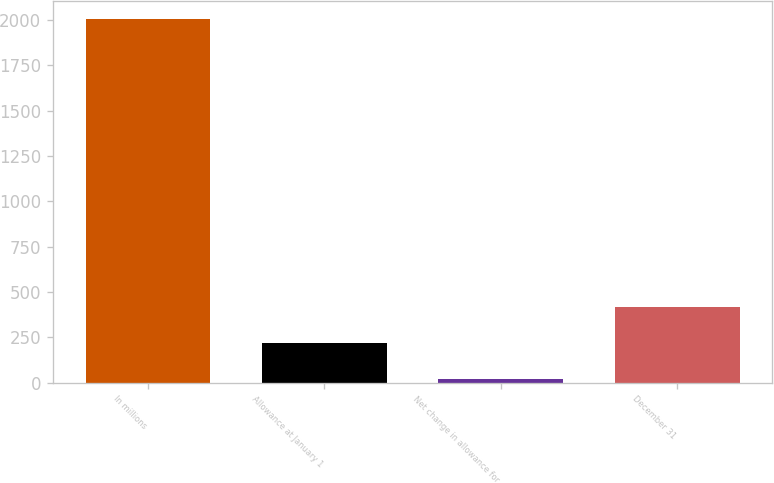Convert chart to OTSL. <chart><loc_0><loc_0><loc_500><loc_500><bar_chart><fcel>In millions<fcel>Allowance at January 1<fcel>Net change in allowance for<fcel>December 31<nl><fcel>2006<fcel>218.6<fcel>20<fcel>417.2<nl></chart> 